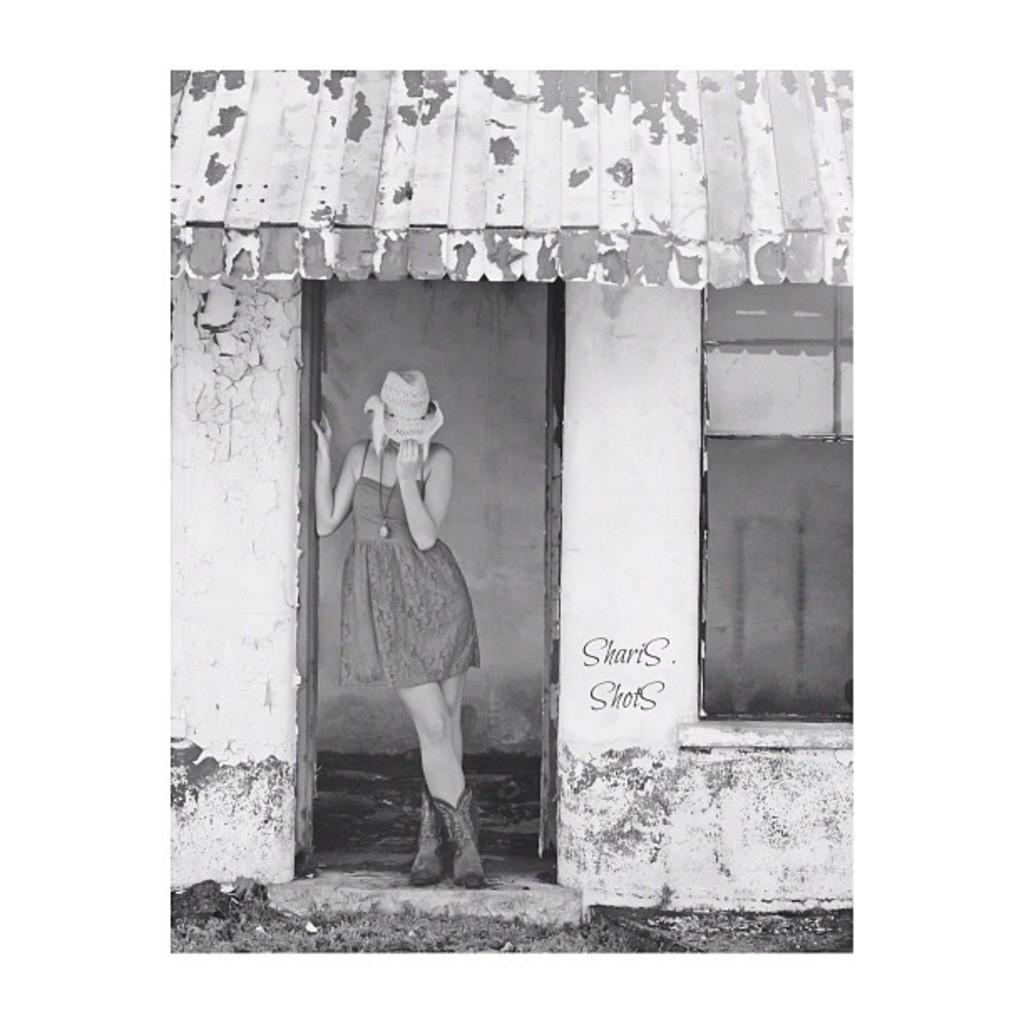Describe this image in one or two sentences. In this black and white image, we can see a shelter house. There is a person in the middle of the image standing and wearing a hat. There is a window on the right side of the image. 